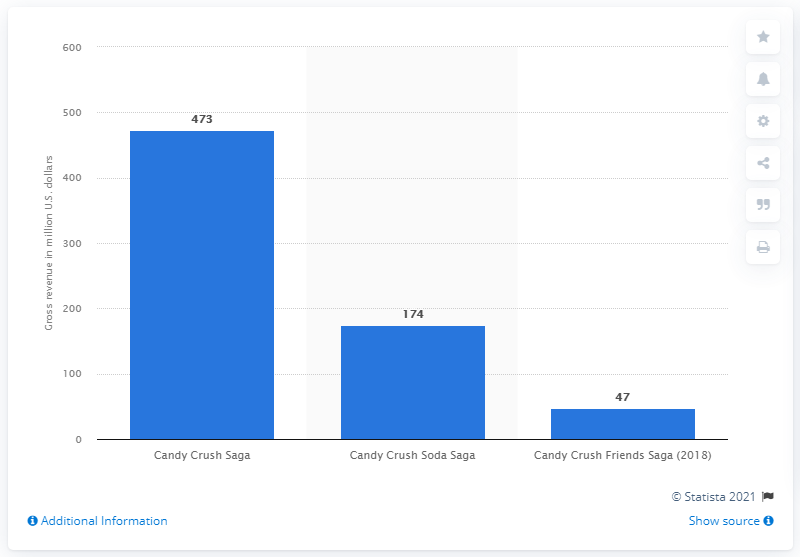Specify some key components in this picture. In the first nine months of 2020, Candy Crush Saga generated revenue of approximately $473 million. 